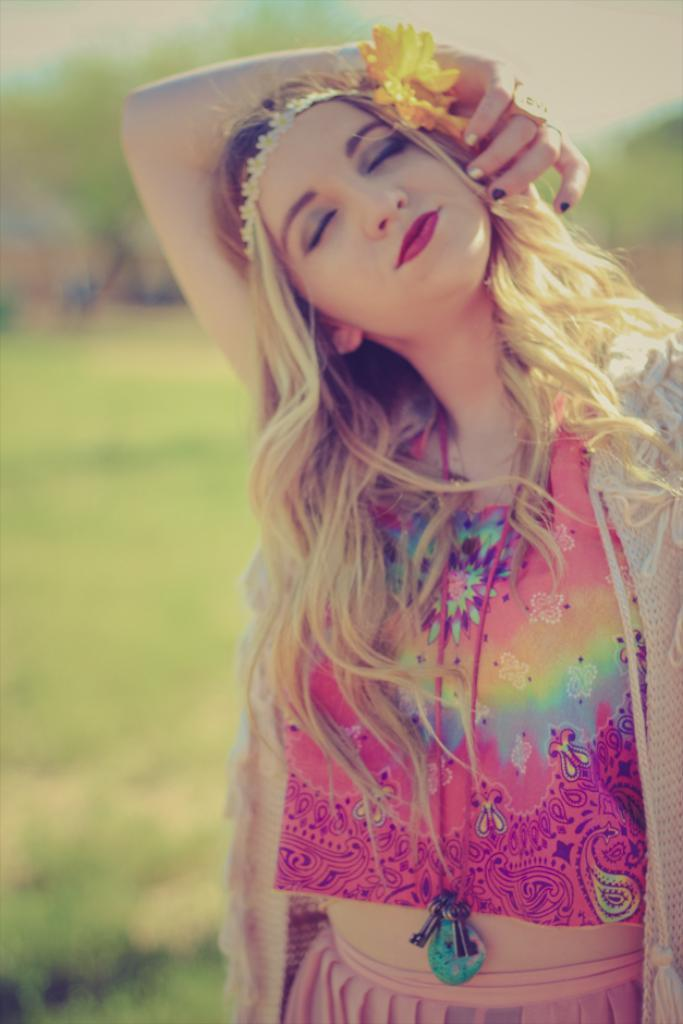What is the main subject in the foreground of the image? There is a woman in the foreground of the image. What is the woman doing in the image? The woman is standing with her eyes closed and has a hand over her head. What is the woman wearing in the image? The woman is wearing a cream coat. What can be seen in the background of the image? There is greenery in the background of the image. What type of owl can be seen sitting on the woman's shoulder in the image? There is no owl present in the image; the woman is standing alone with her eyes closed and a hand over her head. How many children does the woman have, and what are their names? The image does not provide information about the woman's children or their names. 